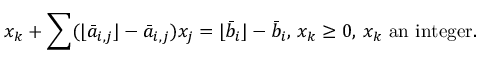<formula> <loc_0><loc_0><loc_500><loc_500>x _ { k } + \sum ( \lfloor { \bar { a } } _ { i , j } \rfloor - { \bar { a } } _ { i , j } ) x _ { j } = \lfloor { \bar { b } } _ { i } \rfloor - { \bar { b } } _ { i } , \, x _ { k } \geq 0 , \, x _ { k } { a n i n t e g e r } .</formula> 